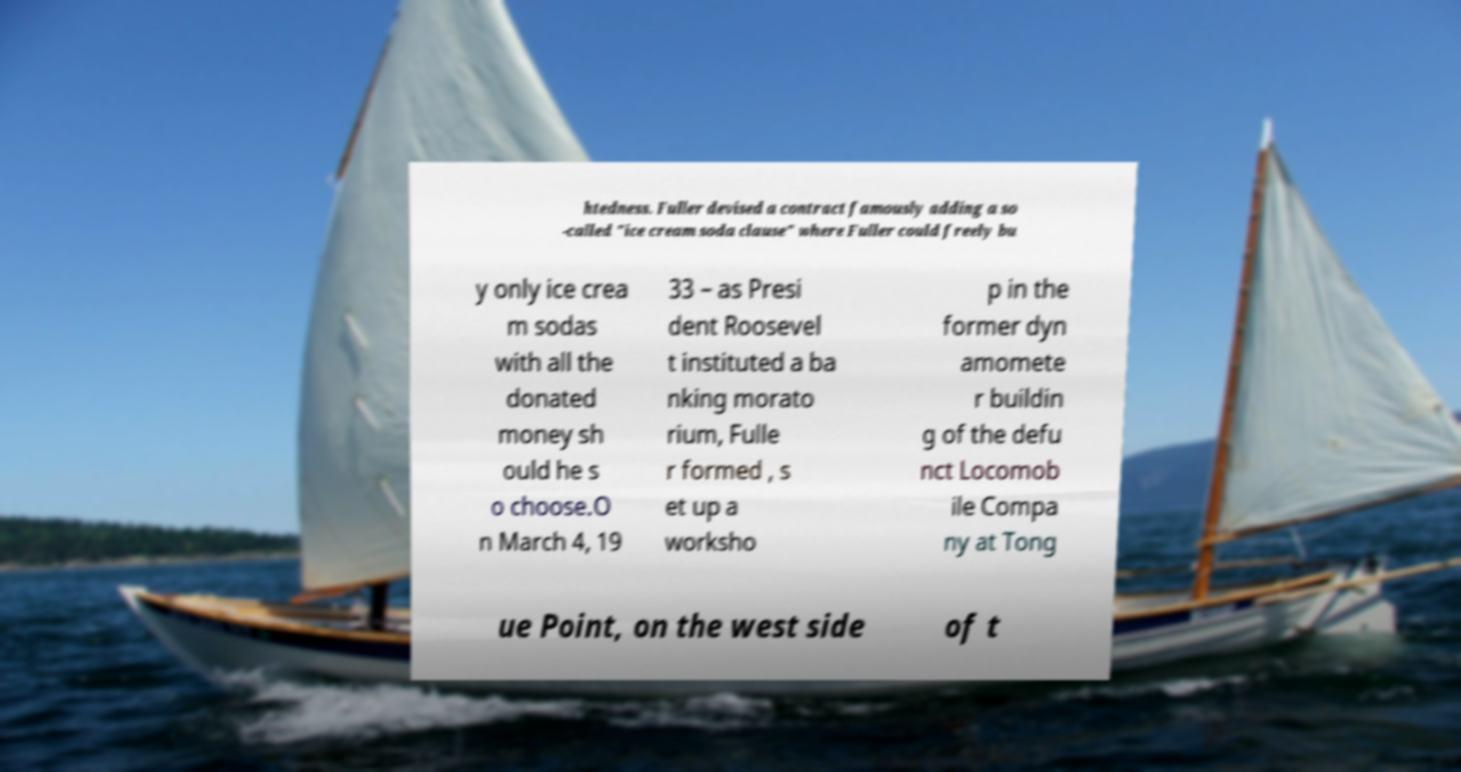Please read and relay the text visible in this image. What does it say? htedness. Fuller devised a contract famously adding a so -called "ice cream soda clause" where Fuller could freely bu y only ice crea m sodas with all the donated money sh ould he s o choose.O n March 4, 19 33 – as Presi dent Roosevel t instituted a ba nking morato rium, Fulle r formed , s et up a worksho p in the former dyn amomete r buildin g of the defu nct Locomob ile Compa ny at Tong ue Point, on the west side of t 